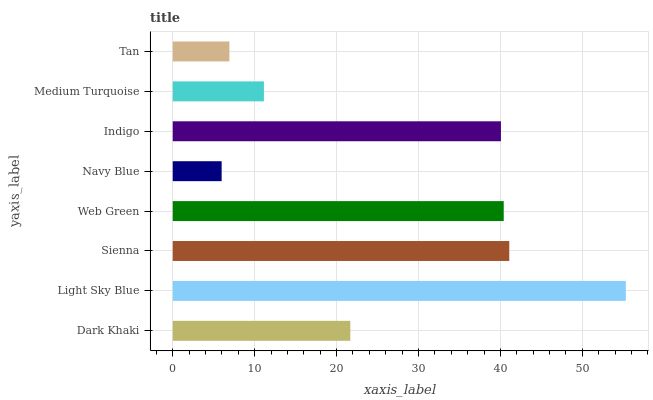Is Navy Blue the minimum?
Answer yes or no. Yes. Is Light Sky Blue the maximum?
Answer yes or no. Yes. Is Sienna the minimum?
Answer yes or no. No. Is Sienna the maximum?
Answer yes or no. No. Is Light Sky Blue greater than Sienna?
Answer yes or no. Yes. Is Sienna less than Light Sky Blue?
Answer yes or no. Yes. Is Sienna greater than Light Sky Blue?
Answer yes or no. No. Is Light Sky Blue less than Sienna?
Answer yes or no. No. Is Indigo the high median?
Answer yes or no. Yes. Is Dark Khaki the low median?
Answer yes or no. Yes. Is Navy Blue the high median?
Answer yes or no. No. Is Light Sky Blue the low median?
Answer yes or no. No. 